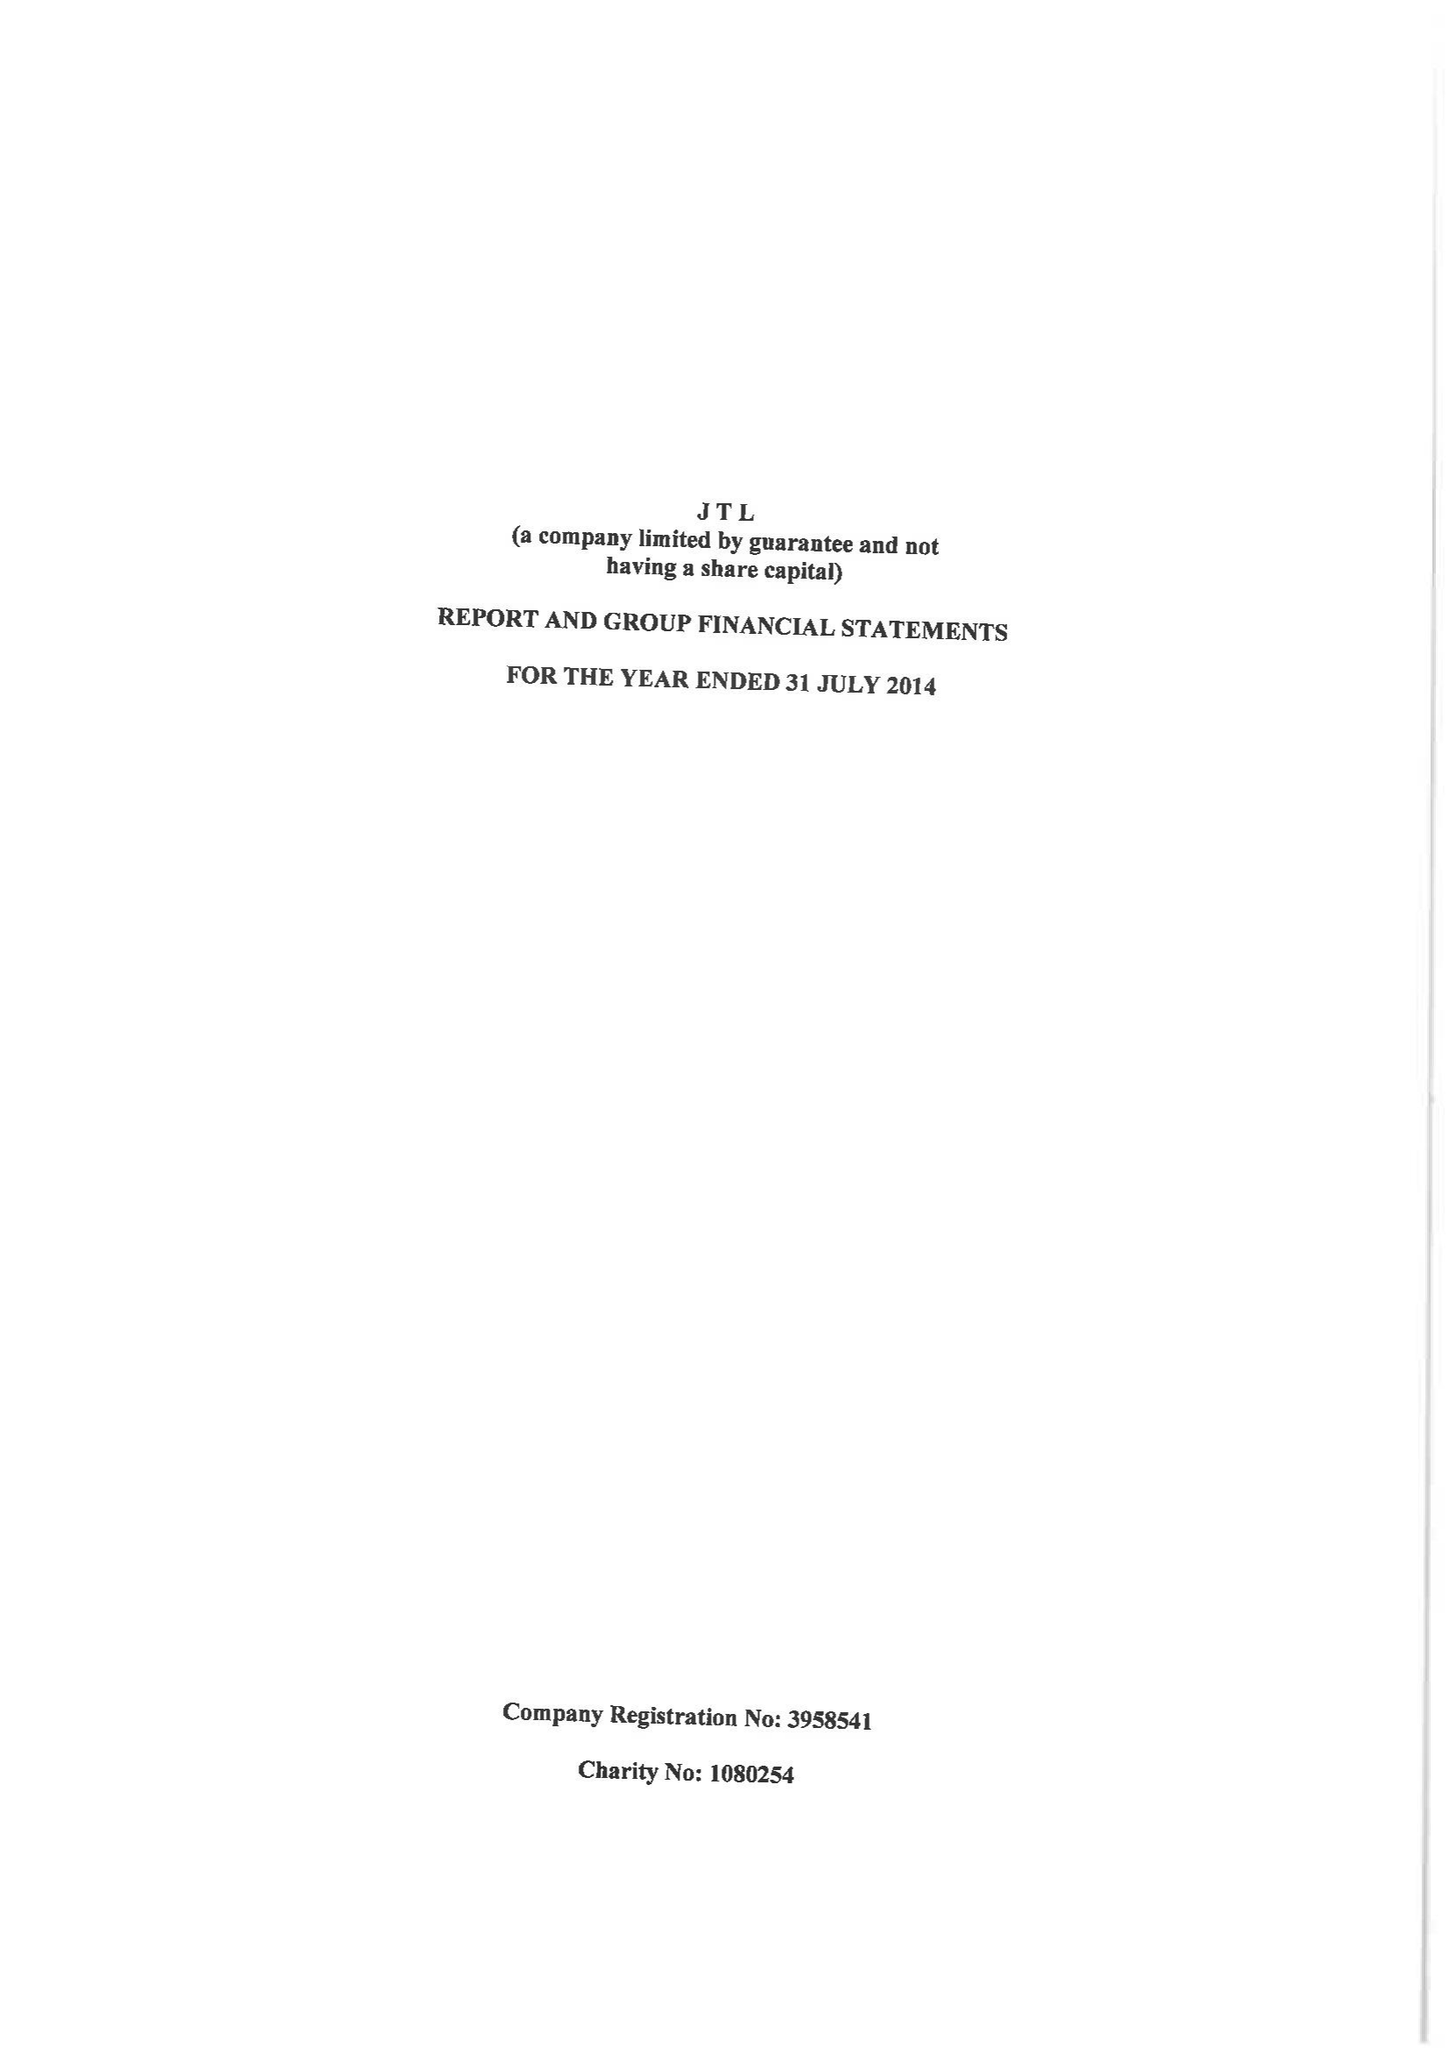What is the value for the income_annually_in_british_pounds?
Answer the question using a single word or phrase. 20002297.00 